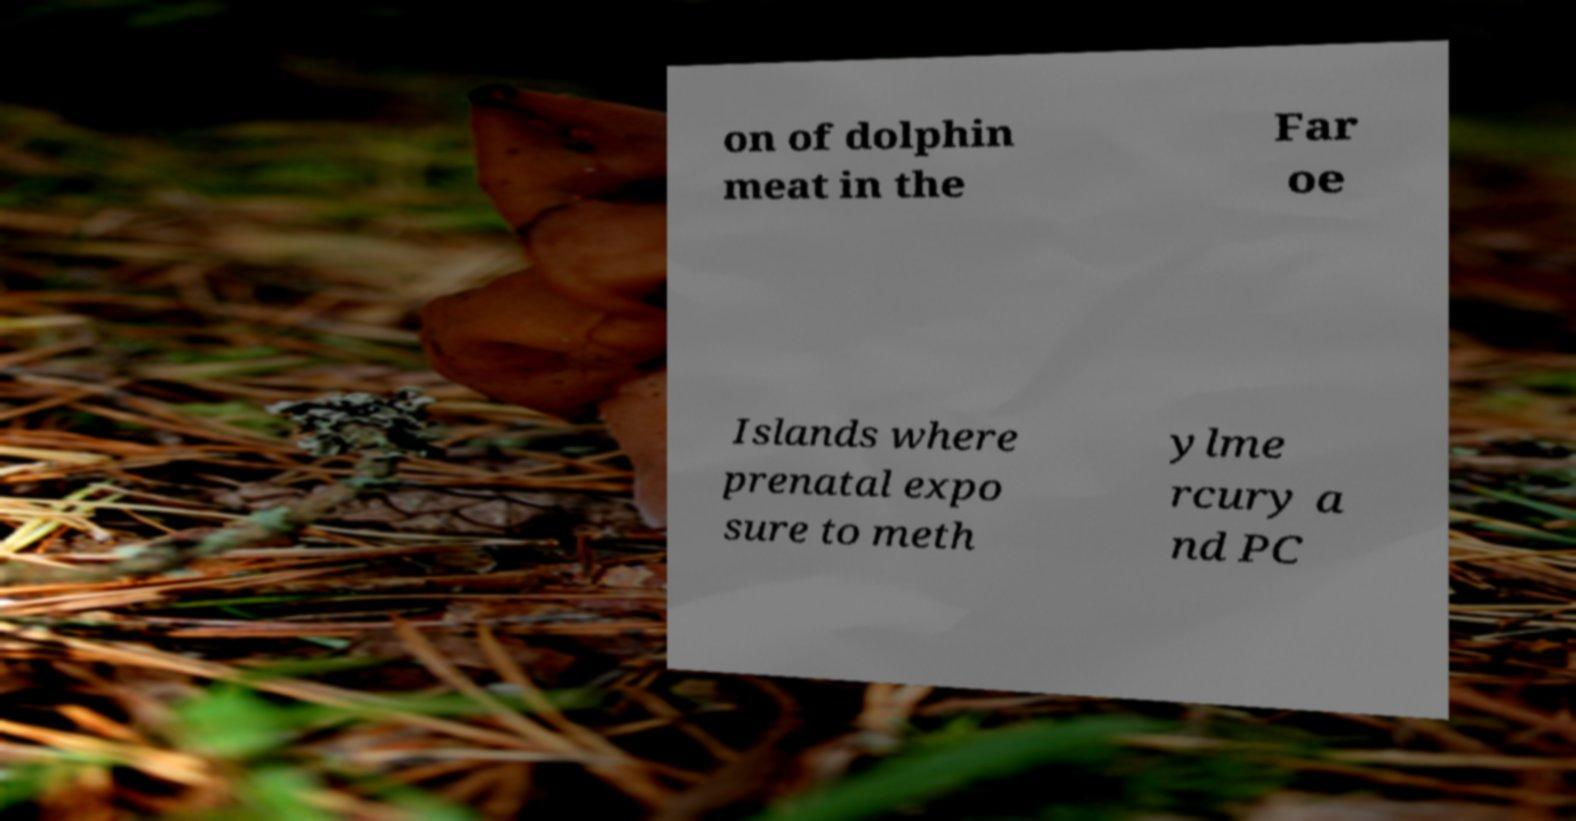Could you assist in decoding the text presented in this image and type it out clearly? on of dolphin meat in the Far oe Islands where prenatal expo sure to meth ylme rcury a nd PC 